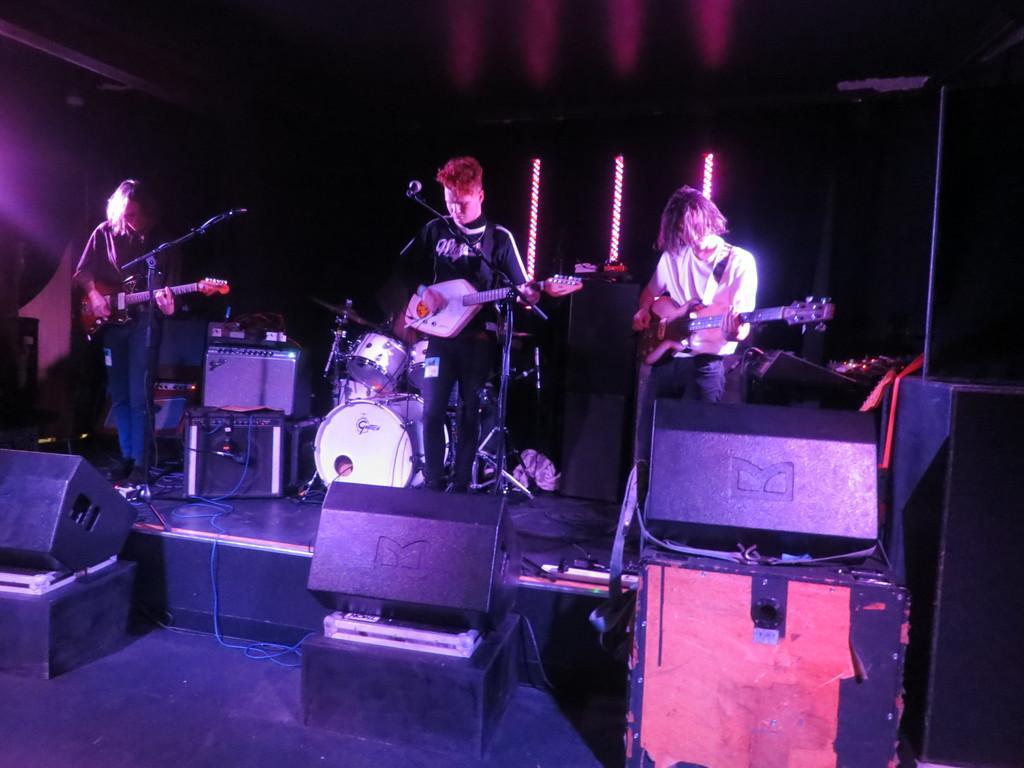Could you give a brief overview of what you see in this image? This picture describes about three people they are standing in front of microphone and holding some musical instruments in front of them we can see some musical instruments. 